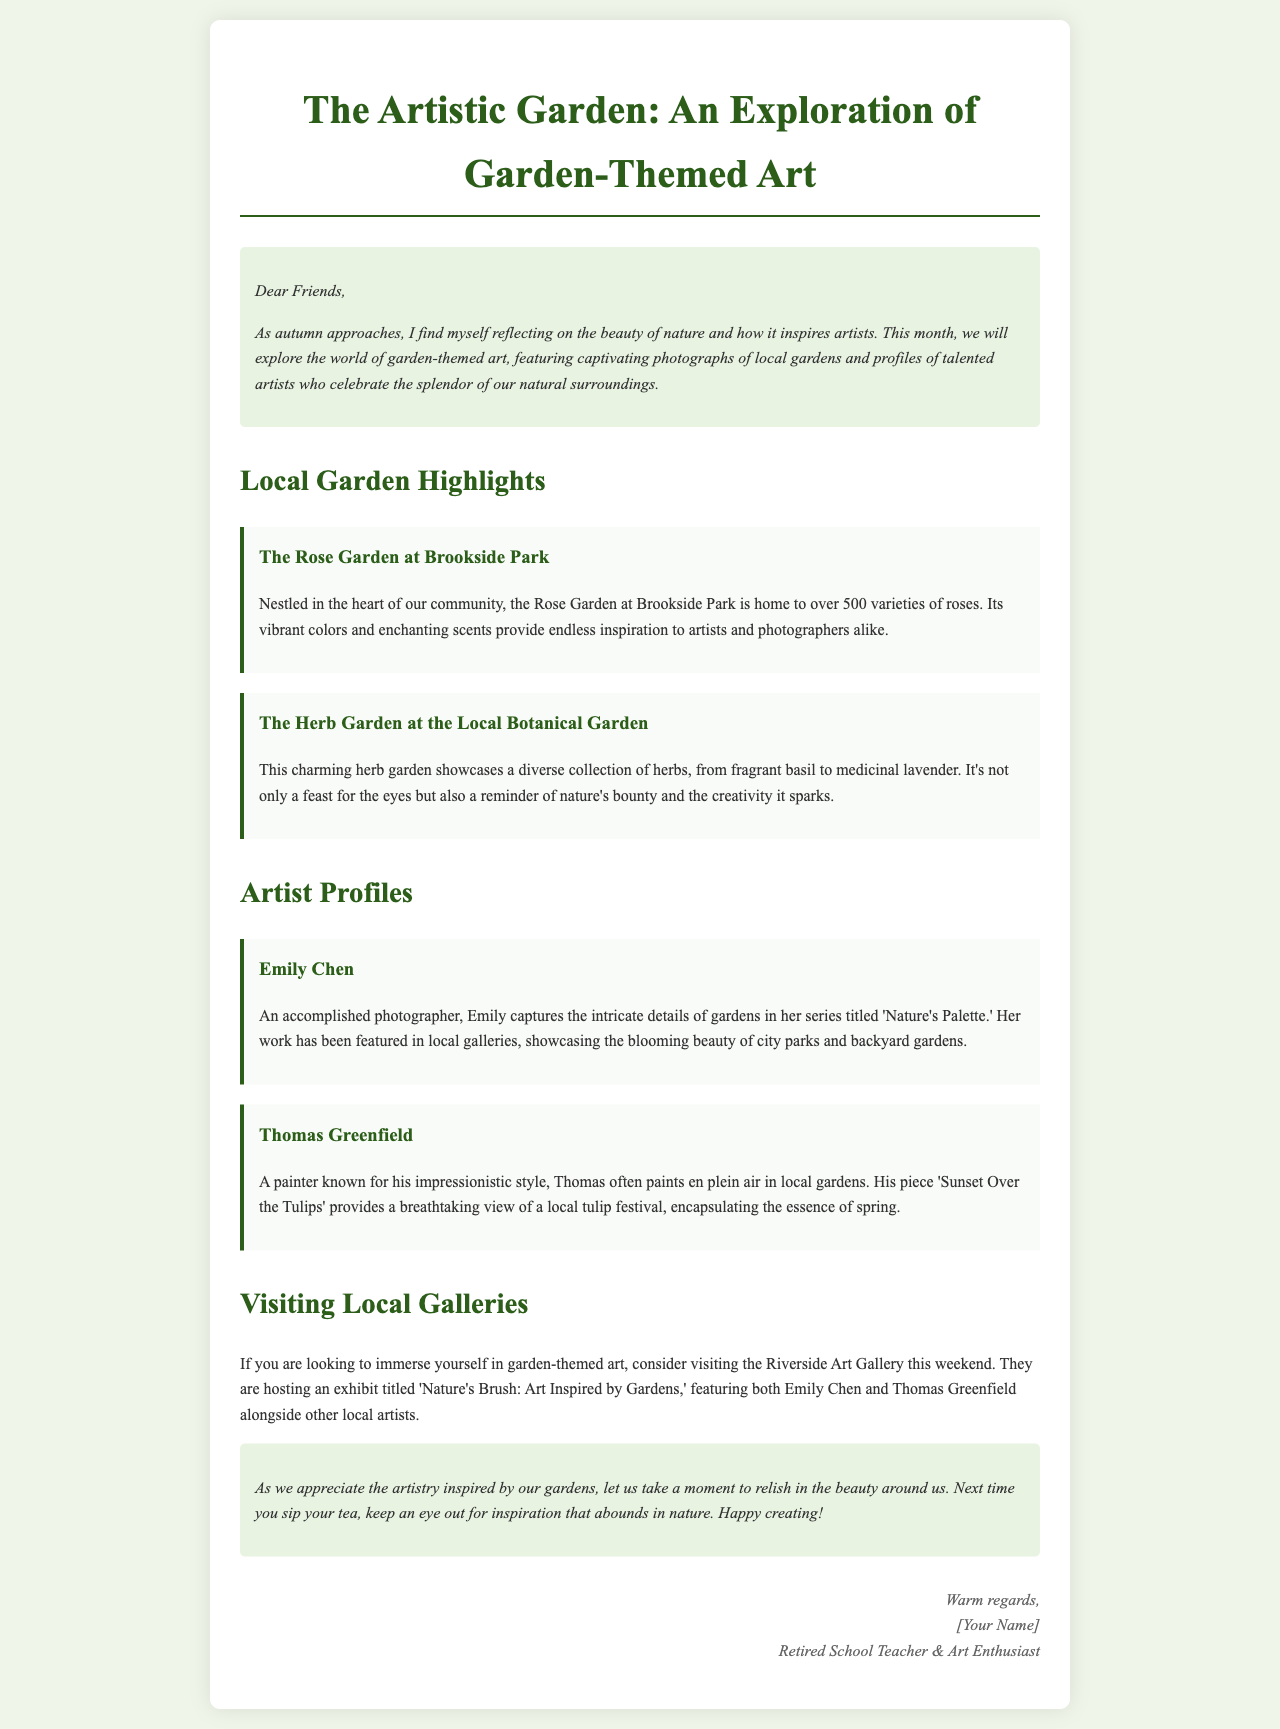What is the title of the newsletter? The title of the newsletter is presented at the top of the document, stating the focus on garden-themed art.
Answer: The Artistic Garden: An Exploration of Garden-Themed Art How many varieties of roses are in the Rose Garden at Brookside Park? The document specifies that the Rose Garden features over 500 varieties of roses, highlighting its diversity.
Answer: 500 What is the name of the artist who captures gardens in her photography? The document provides the name of the artist who is an accomplished photographer specializing in garden themes.
Answer: Emily Chen What is the title of Thomas Greenfield's painting? The document mentions the specific painting by the artist, exemplifying his impressionistic approach to garden art.
Answer: Sunset Over the Tulips What event is happening at the Riverside Art Gallery this weekend? The document discusses a specific exhibit at the gallery that relates to garden-themed art, mentioning the title of the exhibit.
Answer: Nature's Brush: Art Inspired by Gardens What artistic style is Thomas Greenfield known for? The document describes the artist's painting technique and gives insight into how he creates his garden art.
Answer: Impressionistic style What kind of garden is at the Local Botanical Garden? The document describes the type of garden featured in the article, emphasizing its focus on herbs.
Answer: Herb Garden Why does the newsletter mention sipping tea? The newsletter encourages readers to find inspiration in nature, suggesting a relaxing activity to reflect on beauty while enjoying a beverage.
Answer: Finding inspiration 